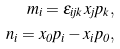Convert formula to latex. <formula><loc_0><loc_0><loc_500><loc_500>m _ { i } = \epsilon _ { i j k } x _ { j } p _ { k } , \\ n _ { i } = x _ { 0 } p _ { i } - x _ { i } p _ { 0 } ,</formula> 